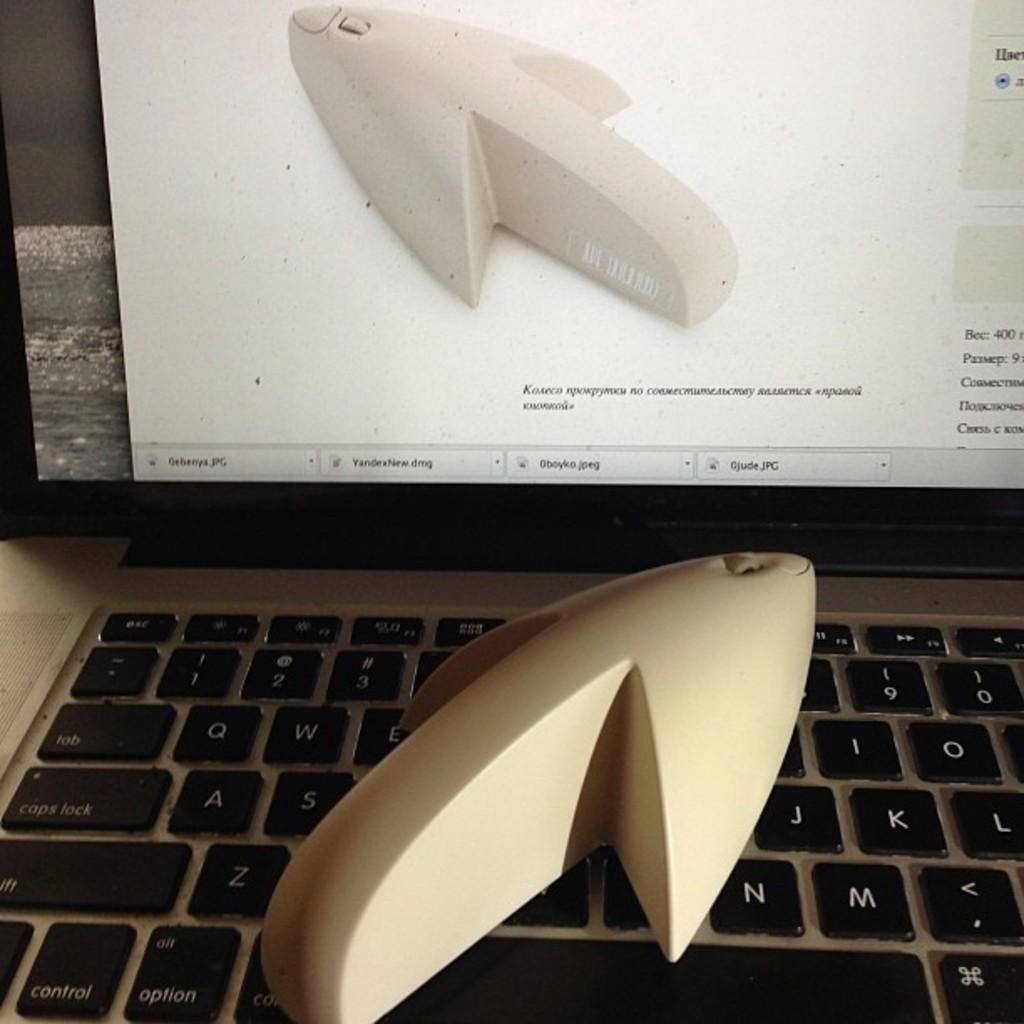What kind of file is the tab on bottom right?
Your answer should be very brief. Jpg. 